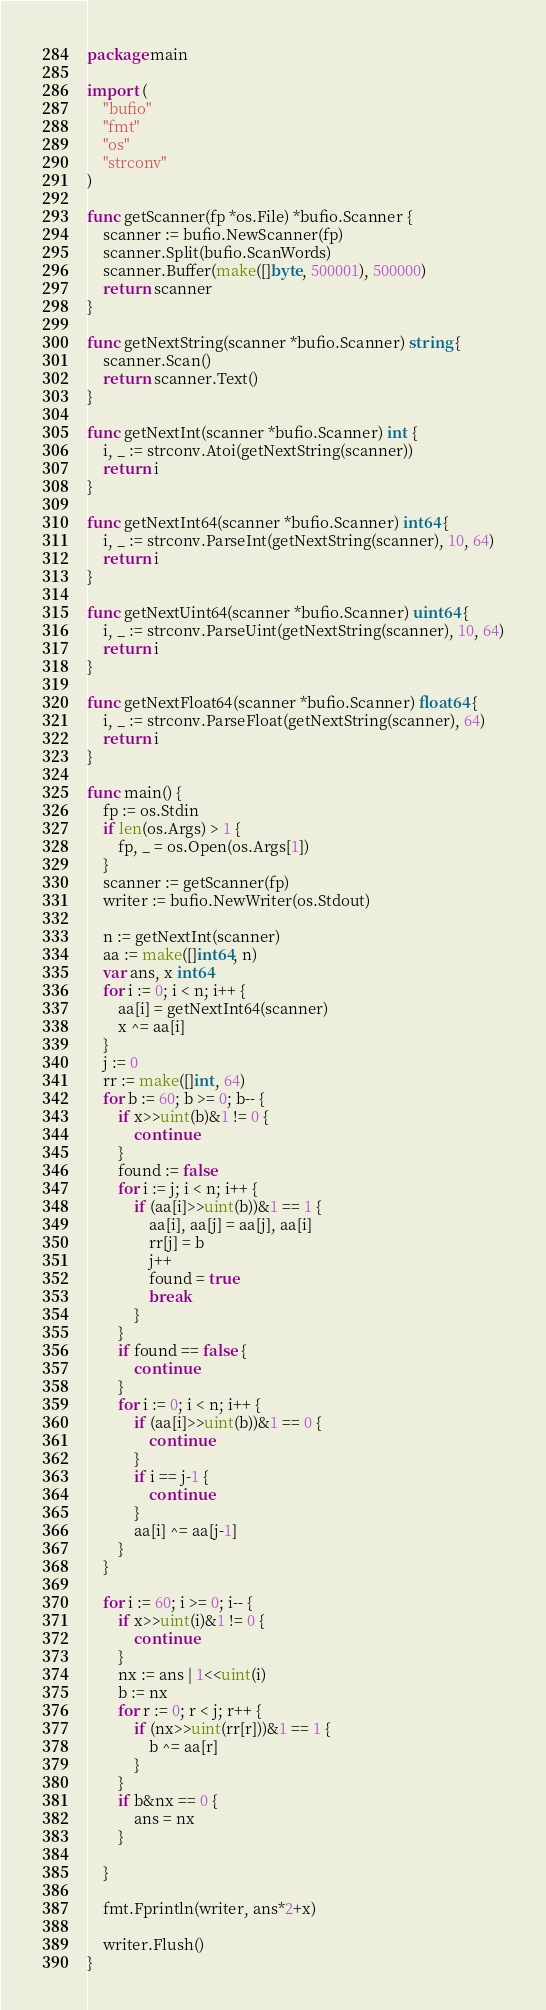<code> <loc_0><loc_0><loc_500><loc_500><_Go_>package main

import (
	"bufio"
	"fmt"
	"os"
	"strconv"
)

func getScanner(fp *os.File) *bufio.Scanner {
	scanner := bufio.NewScanner(fp)
	scanner.Split(bufio.ScanWords)
	scanner.Buffer(make([]byte, 500001), 500000)
	return scanner
}

func getNextString(scanner *bufio.Scanner) string {
	scanner.Scan()
	return scanner.Text()
}

func getNextInt(scanner *bufio.Scanner) int {
	i, _ := strconv.Atoi(getNextString(scanner))
	return i
}

func getNextInt64(scanner *bufio.Scanner) int64 {
	i, _ := strconv.ParseInt(getNextString(scanner), 10, 64)
	return i
}

func getNextUint64(scanner *bufio.Scanner) uint64 {
	i, _ := strconv.ParseUint(getNextString(scanner), 10, 64)
	return i
}

func getNextFloat64(scanner *bufio.Scanner) float64 {
	i, _ := strconv.ParseFloat(getNextString(scanner), 64)
	return i
}

func main() {
	fp := os.Stdin
	if len(os.Args) > 1 {
		fp, _ = os.Open(os.Args[1])
	}
	scanner := getScanner(fp)
	writer := bufio.NewWriter(os.Stdout)

	n := getNextInt(scanner)
	aa := make([]int64, n)
	var ans, x int64
	for i := 0; i < n; i++ {
		aa[i] = getNextInt64(scanner)
		x ^= aa[i]
	}
	j := 0
	rr := make([]int, 64)
	for b := 60; b >= 0; b-- {
		if x>>uint(b)&1 != 0 {
			continue
		}
		found := false
		for i := j; i < n; i++ {
			if (aa[i]>>uint(b))&1 == 1 {
				aa[i], aa[j] = aa[j], aa[i]
				rr[j] = b
				j++
				found = true
				break
			}
		}
		if found == false {
			continue
		}
		for i := 0; i < n; i++ {
			if (aa[i]>>uint(b))&1 == 0 {
				continue
			}
			if i == j-1 {
				continue
			}
			aa[i] ^= aa[j-1]
		}
	}

	for i := 60; i >= 0; i-- {
		if x>>uint(i)&1 != 0 {
			continue
		}
		nx := ans | 1<<uint(i)
		b := nx
		for r := 0; r < j; r++ {
			if (nx>>uint(rr[r]))&1 == 1 {
				b ^= aa[r]
			}
		}
		if b&nx == 0 {
			ans = nx
		}

	}

	fmt.Fprintln(writer, ans*2+x)

	writer.Flush()
}
</code> 